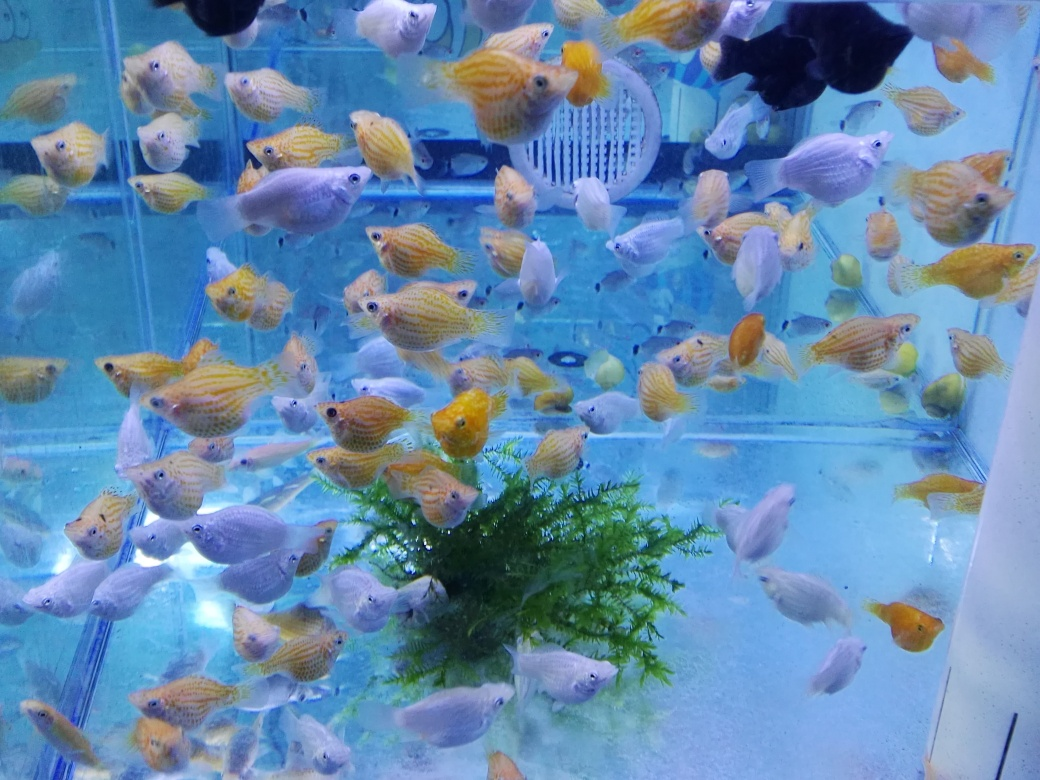Are there any focusing issues in the image?
 no 